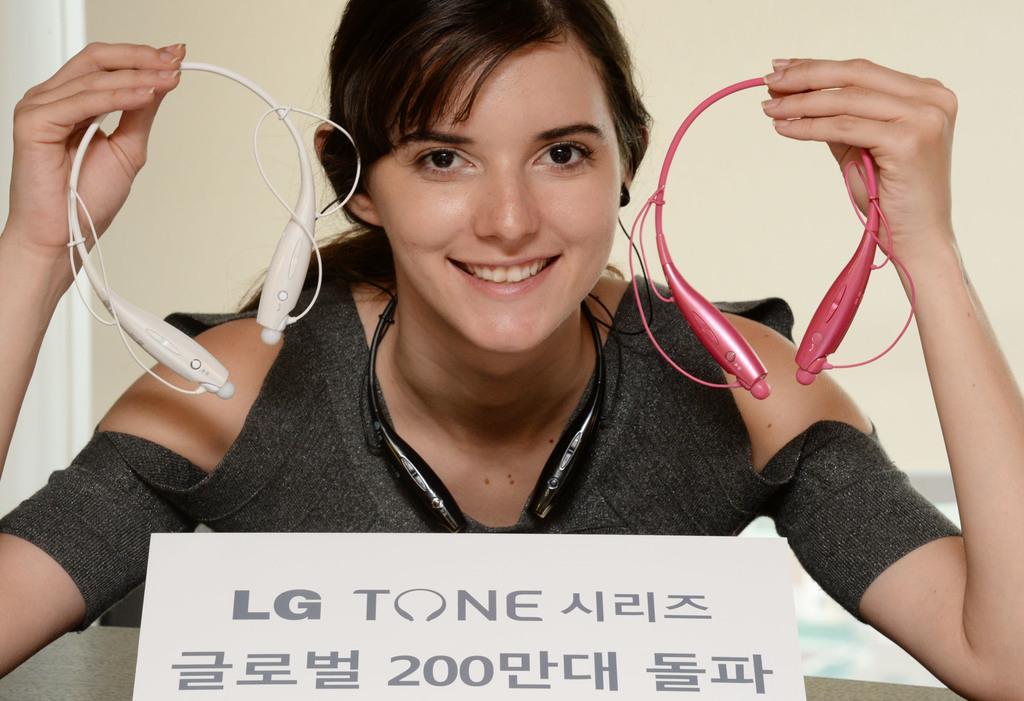Describe this image in one or two sentences. Here in this picture we can see a woman holding Bluetooth headsets in her hands and smiling and in front of her we can see a name board present over there. 